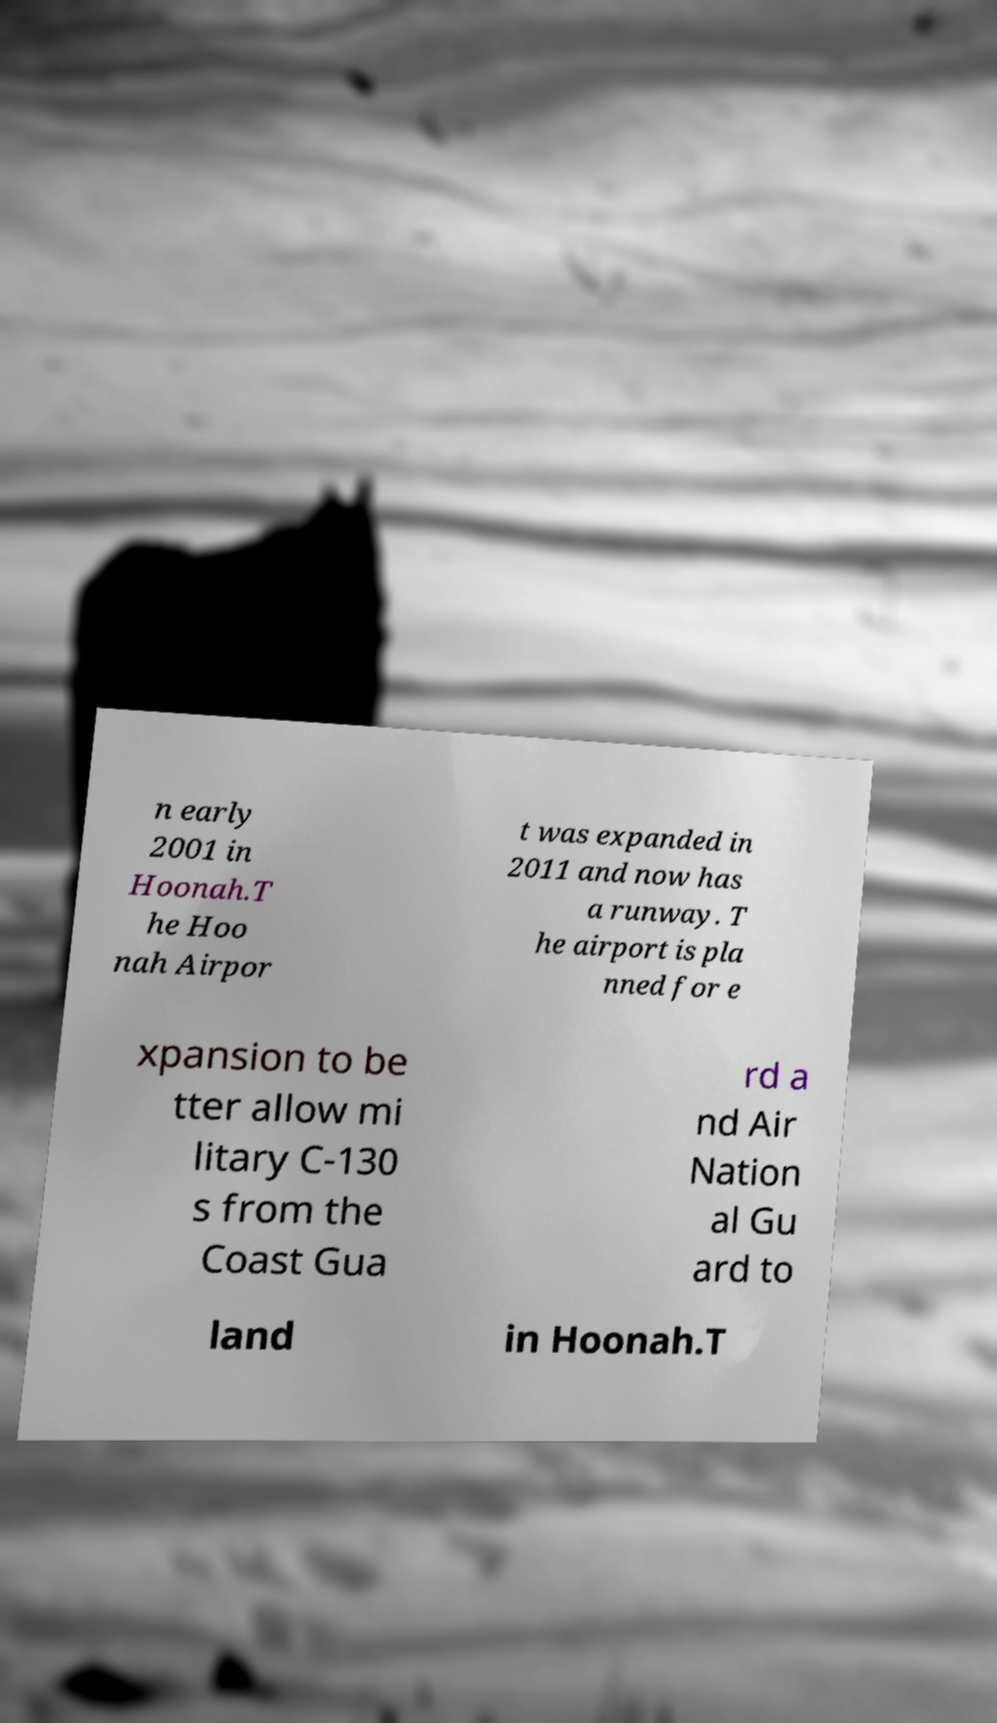Can you accurately transcribe the text from the provided image for me? n early 2001 in Hoonah.T he Hoo nah Airpor t was expanded in 2011 and now has a runway. T he airport is pla nned for e xpansion to be tter allow mi litary C-130 s from the Coast Gua rd a nd Air Nation al Gu ard to land in Hoonah.T 